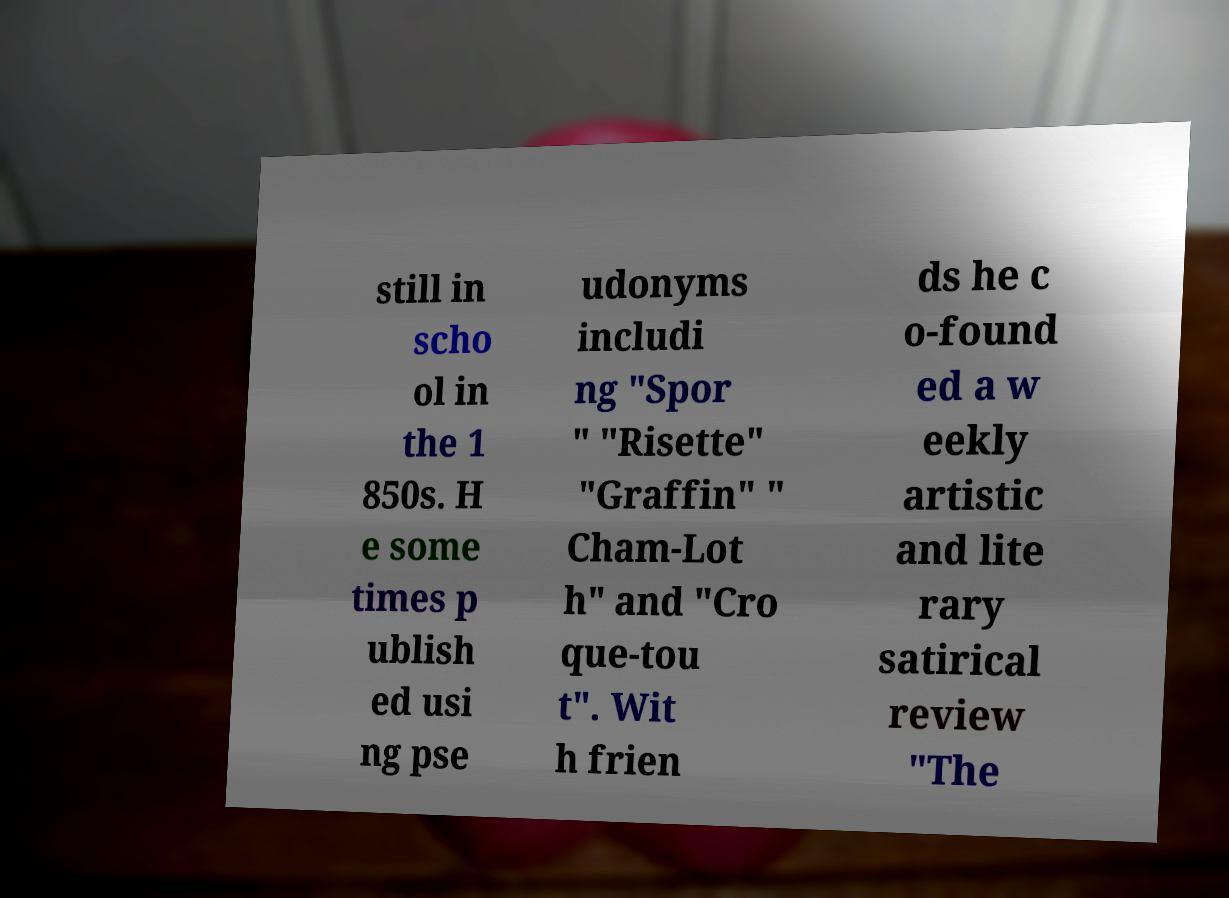I need the written content from this picture converted into text. Can you do that? still in scho ol in the 1 850s. H e some times p ublish ed usi ng pse udonyms includi ng "Spor " "Risette" "Graffin" " Cham-Lot h" and "Cro que-tou t". Wit h frien ds he c o-found ed a w eekly artistic and lite rary satirical review "The 